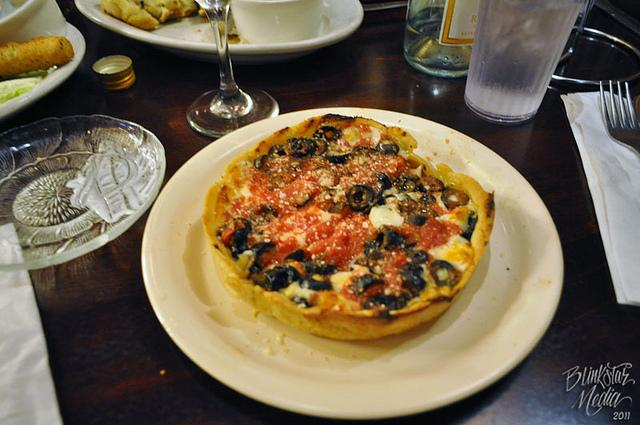What style of pizza is on the plate?

Choices:
A) deep dish
B) neapolitan
C) thin crust
D) stuffed crust deep dish 